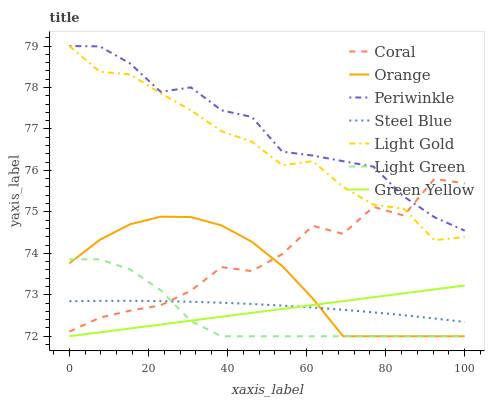Does Light Green have the minimum area under the curve?
Answer yes or no. Yes. Does Periwinkle have the maximum area under the curve?
Answer yes or no. Yes. Does Steel Blue have the minimum area under the curve?
Answer yes or no. No. Does Steel Blue have the maximum area under the curve?
Answer yes or no. No. Is Green Yellow the smoothest?
Answer yes or no. Yes. Is Coral the roughest?
Answer yes or no. Yes. Is Steel Blue the smoothest?
Answer yes or no. No. Is Steel Blue the roughest?
Answer yes or no. No. Does Light Green have the lowest value?
Answer yes or no. Yes. Does Steel Blue have the lowest value?
Answer yes or no. No. Does Light Gold have the highest value?
Answer yes or no. Yes. Does Steel Blue have the highest value?
Answer yes or no. No. Is Steel Blue less than Periwinkle?
Answer yes or no. Yes. Is Light Gold greater than Green Yellow?
Answer yes or no. Yes. Does Green Yellow intersect Steel Blue?
Answer yes or no. Yes. Is Green Yellow less than Steel Blue?
Answer yes or no. No. Is Green Yellow greater than Steel Blue?
Answer yes or no. No. Does Steel Blue intersect Periwinkle?
Answer yes or no. No. 